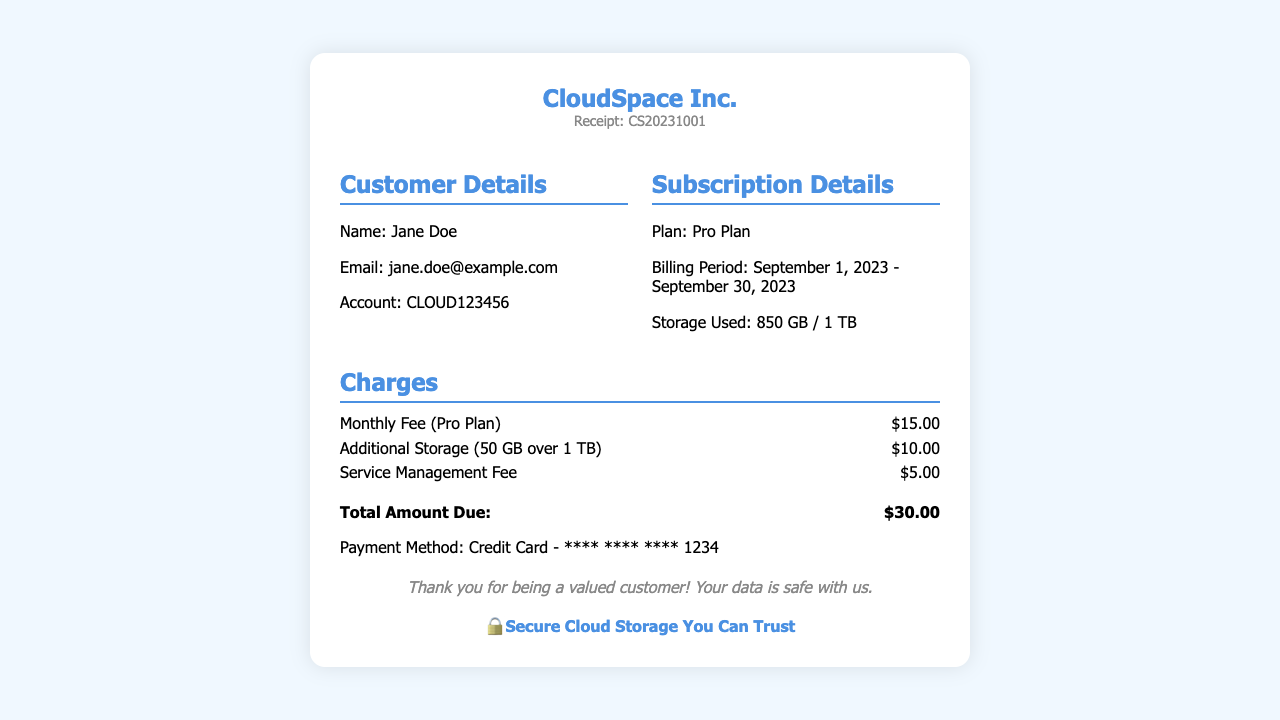What is the customer name? The customer's name is stated in the document under Customer Details as "Jane Doe."
Answer: Jane Doe What is the subscription plan? The plan type is indicated in the Subscription Details section as "Pro Plan."
Answer: Pro Plan What is the billing period? The billing period is defined in the Subscription Details and covers from September 1, 2023, to September 30, 2023.
Answer: September 1, 2023 - September 30, 2023 How much storage was used? The amount of storage used is given in the Subscription Details as "850 GB / 1 TB."
Answer: 850 GB / 1 TB What is the total amount due? The total amount due is calculated by summing the fees listed in the Charges section and is indicated at the end as "$30.00."
Answer: $30.00 What is the payment method? The document specifies the payment method under the Payment Method section as "Credit Card - **** **** **** 1234."
Answer: Credit Card - **** **** **** 1234 Why is there an additional fee? The document mentions an "Additional Storage (50 GB over 1 TB)" fee which indicates that the storage used exceeded the plan limit.
Answer: 50 GB over 1 TB What is the service management fee? The Charges section lists the "Service Management Fee" as one of the fees incurred.
Answer: $5.00 How much was charged for additional storage? The additional storage is charged as shown in the Charges section, specifically stating "$10.00."
Answer: $10.00 